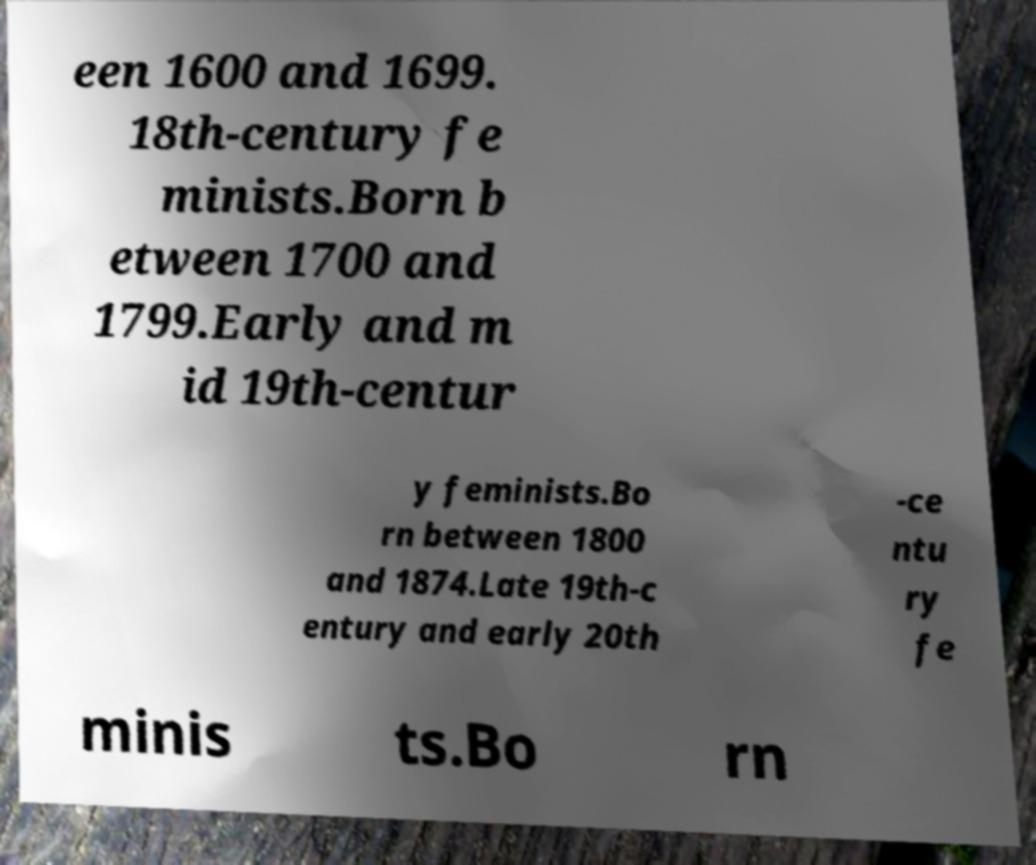Can you accurately transcribe the text from the provided image for me? een 1600 and 1699. 18th-century fe minists.Born b etween 1700 and 1799.Early and m id 19th-centur y feminists.Bo rn between 1800 and 1874.Late 19th-c entury and early 20th -ce ntu ry fe minis ts.Bo rn 